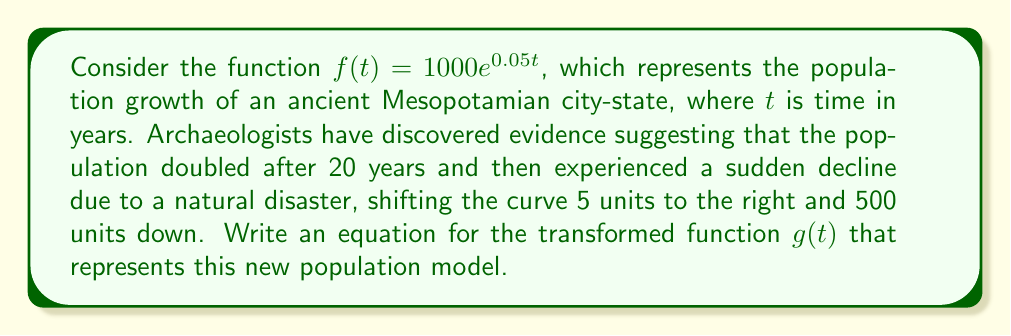Give your solution to this math problem. Let's approach this problem step-by-step:

1) First, we need to verify that the original function indeed doubles after 20 years:
   
   $f(20) = 1000e^{0.05(20)} = 1000e^1 \approx 2718.28$
   
   This is indeed more than double the initial population of 1000.

2) Now, let's consider the transformations:
   - The curve is shifted 5 units to the right, which means we replace $t$ with $(t-5)$
   - The curve is shifted 500 units down, which means we subtract 500 from the function

3) Applying these transformations to the original function:

   $g(t) = 1000e^{0.05(t-5)} - 500$

4) We can simplify this further:
   
   $g(t) = 1000e^{0.05t} \cdot e^{-0.25} - 500$
   
   $g(t) = 1000e^{0.05t} \cdot 0.7788 - 500$
   
   $g(t) = 778.8e^{0.05t} - 500$

This final form represents the transformed function that models the population after the observed changes.
Answer: $g(t) = 778.8e^{0.05t} - 500$ 